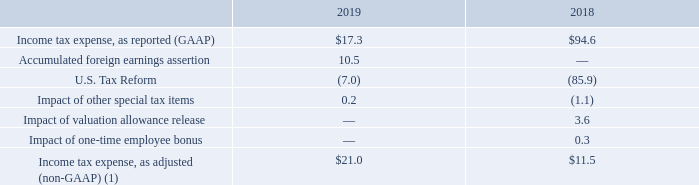Income taxes. Income tax expense and effective annual income tax rates for fiscal 2019 and 2018, as well as information as to the effects of the U.S. Tax Reform in fiscal 2018, were as follows (dollars in millions):
(1) We believe the non-GAAP presentation of income tax expense and the effective annual tax rate excluding special tax items, the one-time employee bonus and restructuring charges provides additional insight over the change from the comparative reporting periods by isolating the impact of these significant, special items. In addition, the Company believes that its income tax expense, as adjusted, and effective tax rate, as adjusted, enhance the ability of investors to analyze the Company’s operating performance and supplement, but do not replace, its income tax expense and effective tax rate calculated in accordance with U.S. GAAP.
Income tax expense for fiscal 2019 was $17.3 million compared to $94.6 million for fiscal 2018. The decrease is primarily due to the $85.9 million impact of Tax
Reform that was recorded in fiscal 2018, which was partially offset by an increase in tax expense due to the global intangible low-taxed income provisions
("GILTI") of Tax Reform in fiscal 2019. Income tax expense also decreased by $10.5 million in fiscal 2019 as the Company reasserted that certain historical
undistributed earnings of two foreign subsidiaries will be permanently reinvested based on the expected working capital requirements of these two foreign
subsidiaries.
The $94.6 million of income tax expense recorded during fiscal 2018 included $85.9 million related to the enactment of Tax Reform. Included in the fiscal 2018 income tax expense was a $3.6 million benefit for the valuation allowance released against the net deferred tax assets in the U.S. as the Company is subject to GILTI.
Which years does the table provide information for Income tax expense? 2019, 2018. What was the amount of U.S. Tax Reform in 2018?
Answer scale should be: million. (85.9). What was the Impact of one-time employee bonus in 2018?
Answer scale should be: million. 0.3. How many years did Income tax expense, as reported (GAAP) exceed $50 million? 2018
Answer: 1. What was the change in the Impact of other special tax items between 2018 and 2019?
Answer scale should be: million. 0.2-(-1.1)
Answer: 1.3. What was the percentage change in the Income tax expense, as adjusted (non-GAAP) between 2018 and 2019?
Answer scale should be: percent. (21.0-11.5)/11.5
Answer: 82.61. 